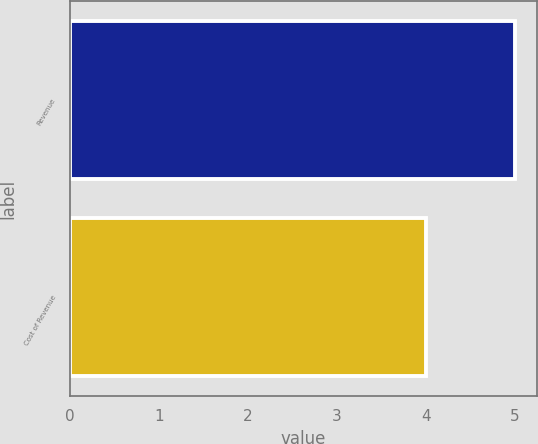<chart> <loc_0><loc_0><loc_500><loc_500><bar_chart><fcel>Revenue<fcel>Cost of Revenue<nl><fcel>5<fcel>4<nl></chart> 